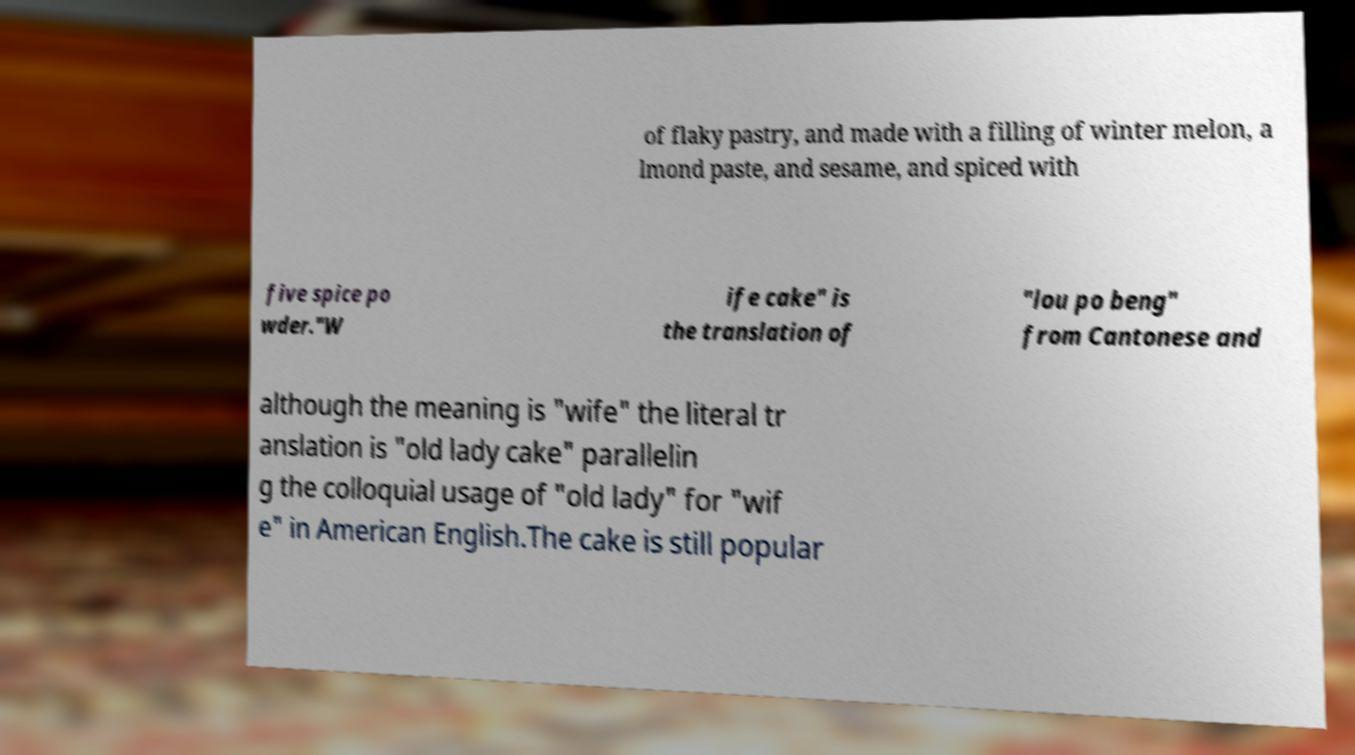There's text embedded in this image that I need extracted. Can you transcribe it verbatim? of flaky pastry, and made with a filling of winter melon, a lmond paste, and sesame, and spiced with five spice po wder."W ife cake" is the translation of "lou po beng" from Cantonese and although the meaning is "wife" the literal tr anslation is "old lady cake" parallelin g the colloquial usage of "old lady" for "wif e" in American English.The cake is still popular 